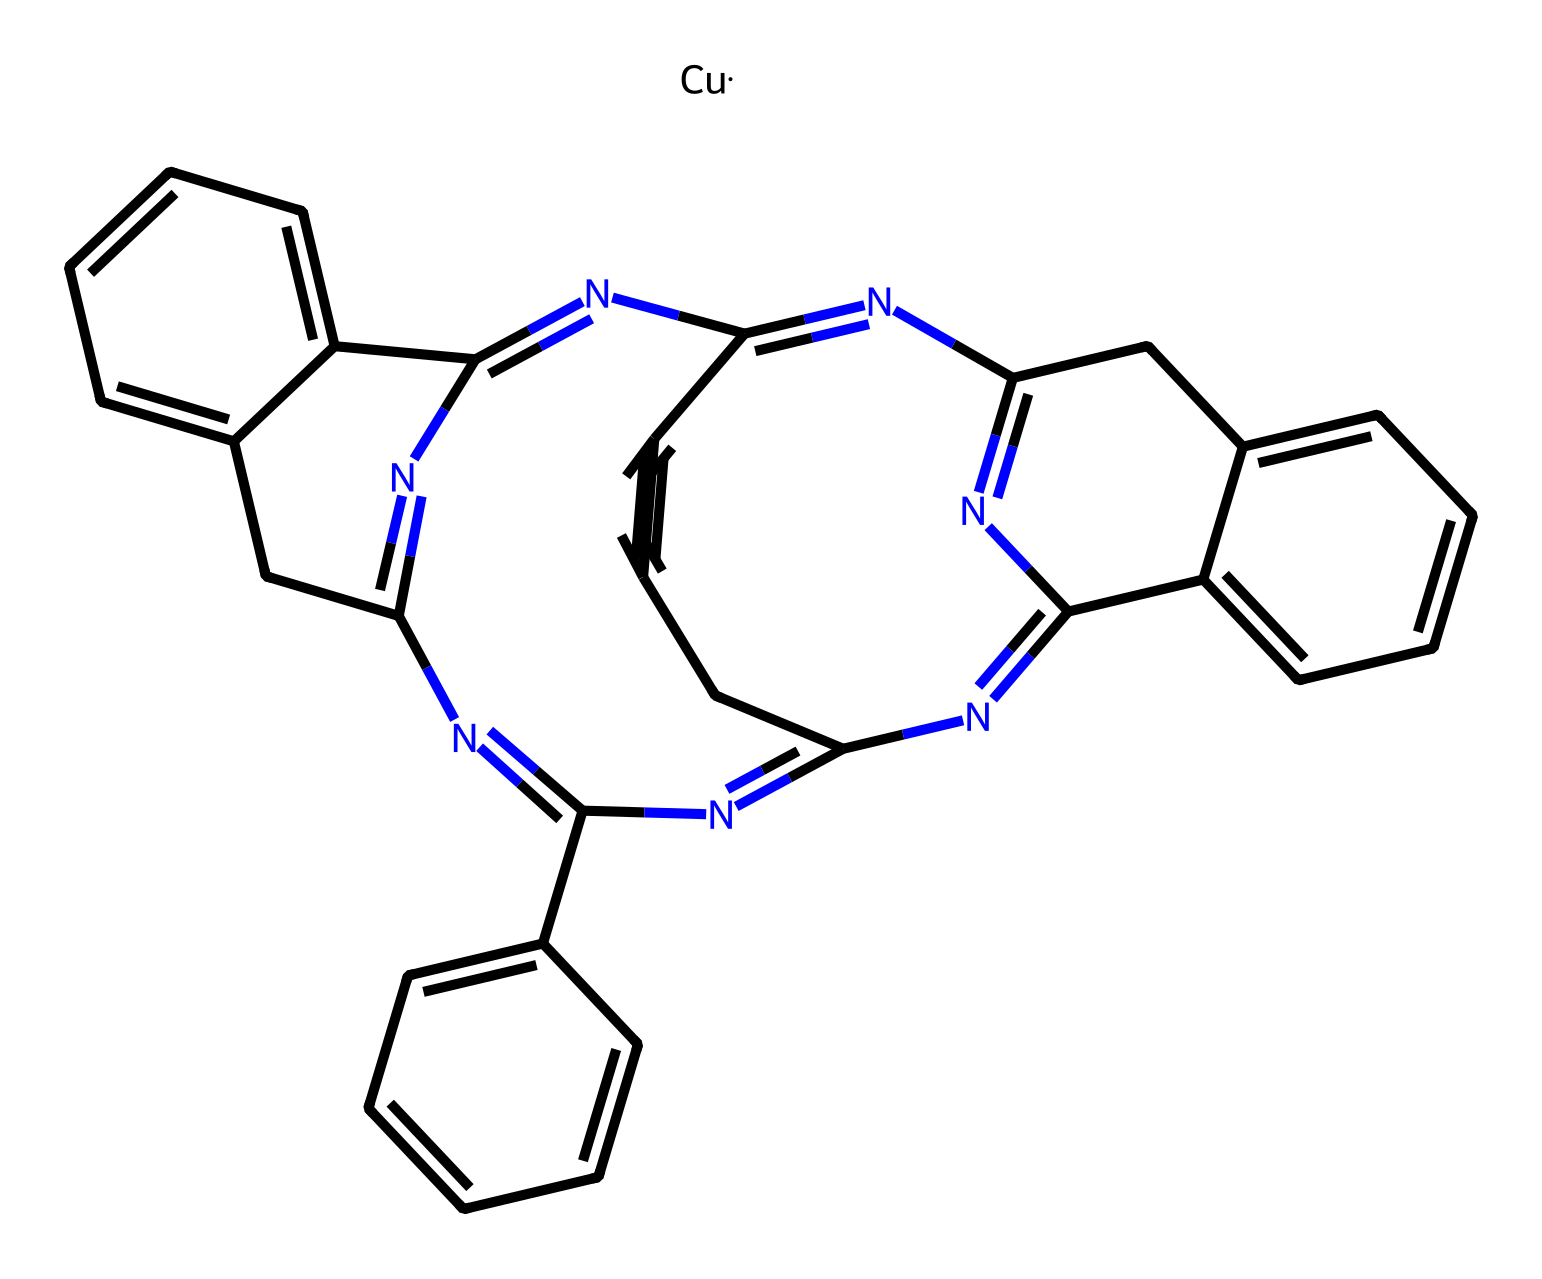What is the central metal ion in this coordination compound? The chemical structure shows the presence of "[Cu]" which indicates that copper is the central metal ion. The copper ion coordinates with the surrounding ligands derived from the phthalocyanine structure.
Answer: copper How many nitrogen atoms are present in this chemical? By counting the nitrogen atoms in the SMILES representation, there are a total of 8 nitrogen atoms in the coordination compound.
Answer: 8 What type of ligands are present in copper phthalocyanine? The structure features a large polycyclic arrangement, which indicates that the ligands are described as π-acceptor ligands, typical for phthalocyanine complexes.
Answer: π-acceptor ligands What type of structure does the coordination compound exhibit? The arrangement of the structure and its planar rings suggest that it exhibits a planar, conjugated structure characteristic of phthalocyanines.
Answer: planar How many aromatic rings does copper phthalocyanine have? The structure contains four benzene-like components (aromatic rings) that are attached to the nitrogen atoms in the phthalocyanine part, leading to a total of 4 aromatic rings.
Answer: 4 What is the coordination number of copper in this compound? The copper ion typically forms four coordinate bonds with the nitrogen atoms surrounding it in a square planar arrangement, confirming a coordination number of 4.
Answer: 4 